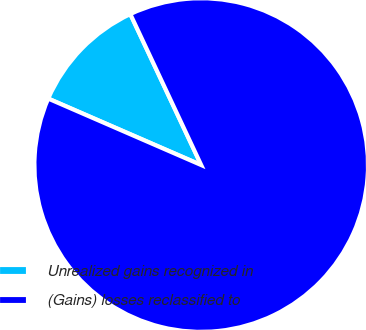<chart> <loc_0><loc_0><loc_500><loc_500><pie_chart><fcel>Unrealized gains recognized in<fcel>(Gains) losses reclassified to<nl><fcel>11.49%<fcel>88.51%<nl></chart> 